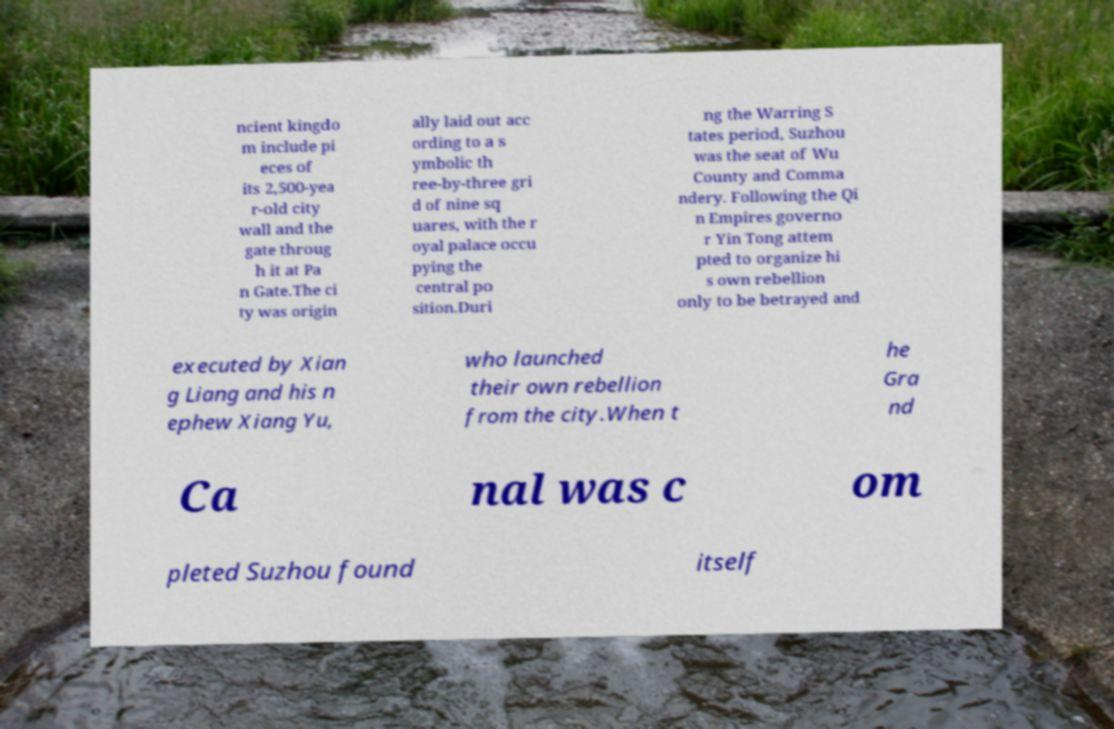There's text embedded in this image that I need extracted. Can you transcribe it verbatim? ncient kingdo m include pi eces of its 2,500-yea r-old city wall and the gate throug h it at Pa n Gate.The ci ty was origin ally laid out acc ording to a s ymbolic th ree-by-three gri d of nine sq uares, with the r oyal palace occu pying the central po sition.Duri ng the Warring S tates period, Suzhou was the seat of Wu County and Comma ndery. Following the Qi n Empires governo r Yin Tong attem pted to organize hi s own rebellion only to be betrayed and executed by Xian g Liang and his n ephew Xiang Yu, who launched their own rebellion from the city.When t he Gra nd Ca nal was c om pleted Suzhou found itself 